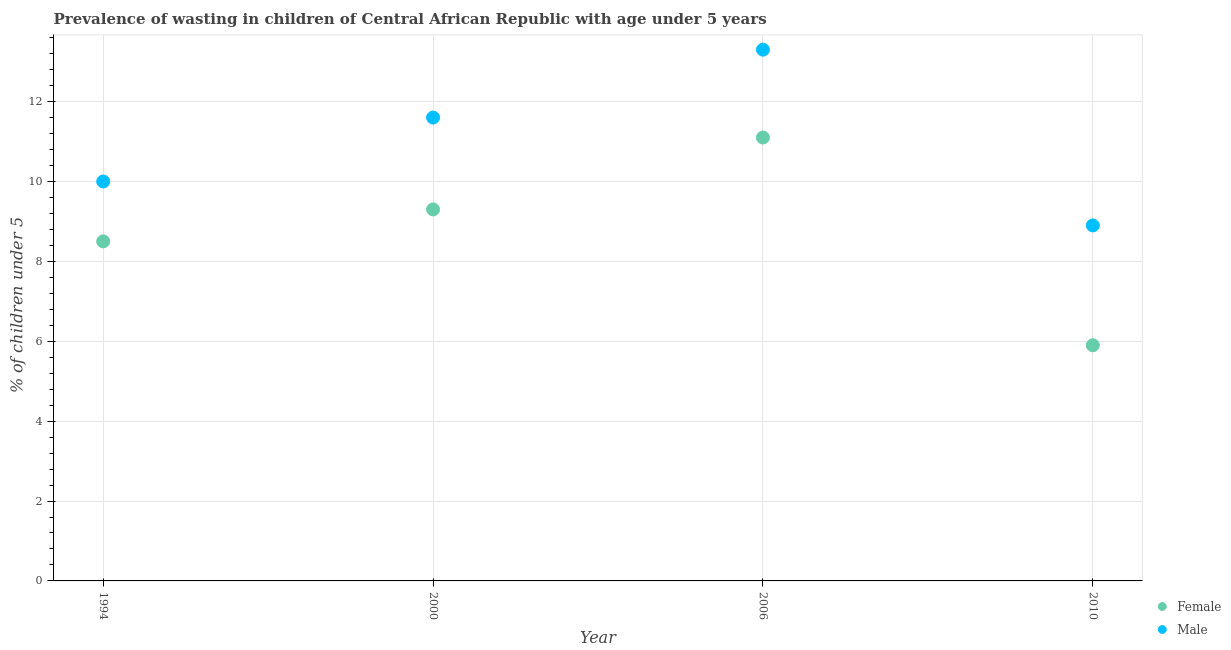Is the number of dotlines equal to the number of legend labels?
Your response must be concise. Yes. What is the percentage of undernourished male children in 2006?
Offer a terse response. 13.3. Across all years, what is the maximum percentage of undernourished male children?
Your answer should be compact. 13.3. Across all years, what is the minimum percentage of undernourished female children?
Ensure brevity in your answer.  5.9. In which year was the percentage of undernourished male children minimum?
Ensure brevity in your answer.  2010. What is the total percentage of undernourished male children in the graph?
Ensure brevity in your answer.  43.8. What is the difference between the percentage of undernourished male children in 2006 and that in 2010?
Ensure brevity in your answer.  4.4. What is the difference between the percentage of undernourished male children in 2010 and the percentage of undernourished female children in 2000?
Make the answer very short. -0.4. What is the average percentage of undernourished male children per year?
Give a very brief answer. 10.95. In the year 2006, what is the difference between the percentage of undernourished male children and percentage of undernourished female children?
Offer a terse response. 2.2. What is the ratio of the percentage of undernourished male children in 1994 to that in 2010?
Give a very brief answer. 1.12. Is the percentage of undernourished female children in 1994 less than that in 2000?
Offer a very short reply. Yes. Is the difference between the percentage of undernourished female children in 2000 and 2010 greater than the difference between the percentage of undernourished male children in 2000 and 2010?
Offer a very short reply. Yes. What is the difference between the highest and the second highest percentage of undernourished male children?
Your answer should be very brief. 1.7. What is the difference between the highest and the lowest percentage of undernourished female children?
Offer a terse response. 5.2. Is the sum of the percentage of undernourished male children in 1994 and 2006 greater than the maximum percentage of undernourished female children across all years?
Give a very brief answer. Yes. Is the percentage of undernourished male children strictly greater than the percentage of undernourished female children over the years?
Your response must be concise. Yes. How many dotlines are there?
Offer a terse response. 2. Does the graph contain grids?
Your answer should be compact. Yes. How are the legend labels stacked?
Keep it short and to the point. Vertical. What is the title of the graph?
Provide a short and direct response. Prevalence of wasting in children of Central African Republic with age under 5 years. What is the label or title of the X-axis?
Ensure brevity in your answer.  Year. What is the label or title of the Y-axis?
Your answer should be very brief.  % of children under 5. What is the  % of children under 5 in Female in 1994?
Make the answer very short. 8.5. What is the  % of children under 5 of Male in 1994?
Your answer should be compact. 10. What is the  % of children under 5 in Female in 2000?
Your answer should be compact. 9.3. What is the  % of children under 5 in Male in 2000?
Give a very brief answer. 11.6. What is the  % of children under 5 of Female in 2006?
Give a very brief answer. 11.1. What is the  % of children under 5 in Male in 2006?
Provide a succinct answer. 13.3. What is the  % of children under 5 of Female in 2010?
Offer a very short reply. 5.9. What is the  % of children under 5 in Male in 2010?
Offer a terse response. 8.9. Across all years, what is the maximum  % of children under 5 in Female?
Your answer should be compact. 11.1. Across all years, what is the maximum  % of children under 5 in Male?
Provide a short and direct response. 13.3. Across all years, what is the minimum  % of children under 5 in Female?
Offer a terse response. 5.9. Across all years, what is the minimum  % of children under 5 in Male?
Make the answer very short. 8.9. What is the total  % of children under 5 in Female in the graph?
Give a very brief answer. 34.8. What is the total  % of children under 5 of Male in the graph?
Your response must be concise. 43.8. What is the difference between the  % of children under 5 of Female in 1994 and that in 2010?
Provide a short and direct response. 2.6. What is the difference between the  % of children under 5 of Male in 1994 and that in 2010?
Give a very brief answer. 1.1. What is the difference between the  % of children under 5 in Female in 2000 and that in 2010?
Your answer should be very brief. 3.4. What is the difference between the  % of children under 5 in Male in 2006 and that in 2010?
Ensure brevity in your answer.  4.4. What is the difference between the  % of children under 5 of Female in 1994 and the  % of children under 5 of Male in 2000?
Provide a short and direct response. -3.1. What is the difference between the  % of children under 5 of Female in 1994 and the  % of children under 5 of Male in 2006?
Make the answer very short. -4.8. What is the difference between the  % of children under 5 of Female in 1994 and the  % of children under 5 of Male in 2010?
Ensure brevity in your answer.  -0.4. What is the difference between the  % of children under 5 of Female in 2000 and the  % of children under 5 of Male in 2010?
Offer a very short reply. 0.4. What is the average  % of children under 5 in Female per year?
Provide a succinct answer. 8.7. What is the average  % of children under 5 in Male per year?
Provide a succinct answer. 10.95. In the year 1994, what is the difference between the  % of children under 5 of Female and  % of children under 5 of Male?
Your answer should be compact. -1.5. In the year 2000, what is the difference between the  % of children under 5 of Female and  % of children under 5 of Male?
Your answer should be very brief. -2.3. In the year 2006, what is the difference between the  % of children under 5 in Female and  % of children under 5 in Male?
Make the answer very short. -2.2. What is the ratio of the  % of children under 5 of Female in 1994 to that in 2000?
Your answer should be compact. 0.91. What is the ratio of the  % of children under 5 of Male in 1994 to that in 2000?
Provide a short and direct response. 0.86. What is the ratio of the  % of children under 5 of Female in 1994 to that in 2006?
Offer a very short reply. 0.77. What is the ratio of the  % of children under 5 in Male in 1994 to that in 2006?
Provide a succinct answer. 0.75. What is the ratio of the  % of children under 5 in Female in 1994 to that in 2010?
Ensure brevity in your answer.  1.44. What is the ratio of the  % of children under 5 in Male in 1994 to that in 2010?
Provide a succinct answer. 1.12. What is the ratio of the  % of children under 5 of Female in 2000 to that in 2006?
Provide a short and direct response. 0.84. What is the ratio of the  % of children under 5 in Male in 2000 to that in 2006?
Your response must be concise. 0.87. What is the ratio of the  % of children under 5 in Female in 2000 to that in 2010?
Give a very brief answer. 1.58. What is the ratio of the  % of children under 5 of Male in 2000 to that in 2010?
Give a very brief answer. 1.3. What is the ratio of the  % of children under 5 of Female in 2006 to that in 2010?
Provide a short and direct response. 1.88. What is the ratio of the  % of children under 5 in Male in 2006 to that in 2010?
Keep it short and to the point. 1.49. What is the difference between the highest and the lowest  % of children under 5 in Female?
Offer a very short reply. 5.2. 